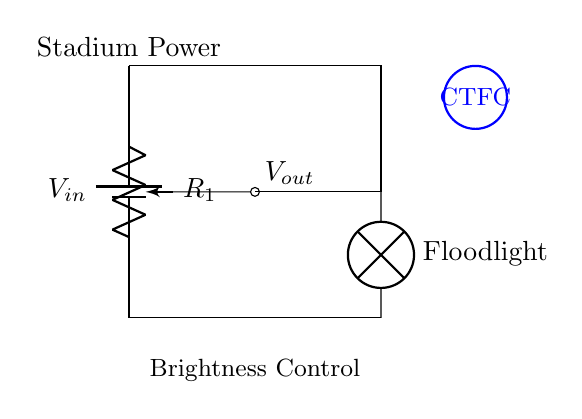What type of circuit is shown? The circuit is a voltage divider, usually comprising resistors or a potentiometer to reduce the voltage. Here, the potentiometer allows for adjustable brightness of the floodlight.
Answer: Voltage divider What component is used for brightness control? The circuit includes a potentiometer, which acts as a variable resistor and can be adjusted to control the brightness of the floodlight.
Answer: Potentiometer What is the input voltage symbol in the circuit? The symbol for the input voltage is represented as V in, which is typically the voltage supplied to the circuit that feeds the floodlight.
Answer: V in Where does the output voltage connect? The output voltage is taken from the wiper of the potentiometer, which is connected to the floodlight to adjust its brightness.
Answer: Floodlight What is the role of the floodlight in this circuit? The floodlight is the load that is powered by the adjusted voltage output from the voltage divider, determining its light intensity based on the voltage level set.
Answer: Load What does the label on top symbolize? The label symbolizes the power supply for the stadium, indicating the source voltage being fed into the circuit.
Answer: Stadium Power What does the CTFC logo represent? The CTFC logo represents Caledonian Thistle F.C., indicating the connection to the football club's identity and location of the circuit usage.
Answer: Caledonian Thistle F.C 